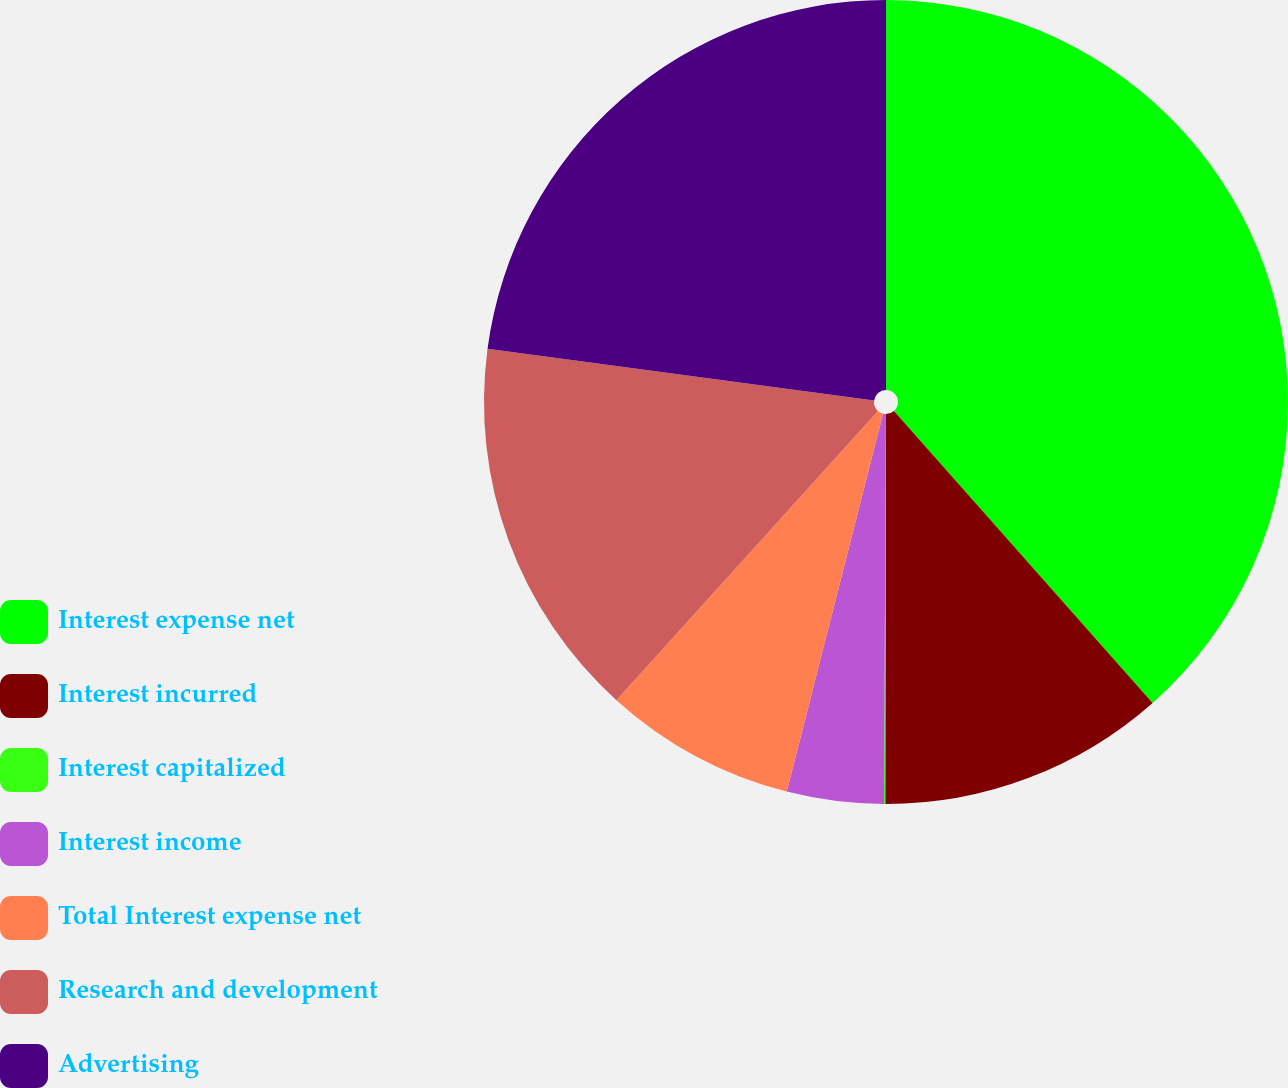Convert chart to OTSL. <chart><loc_0><loc_0><loc_500><loc_500><pie_chart><fcel>Interest expense net<fcel>Interest incurred<fcel>Interest capitalized<fcel>Interest income<fcel>Total Interest expense net<fcel>Research and development<fcel>Advertising<nl><fcel>38.46%<fcel>11.57%<fcel>0.05%<fcel>3.89%<fcel>7.73%<fcel>15.41%<fcel>22.89%<nl></chart> 